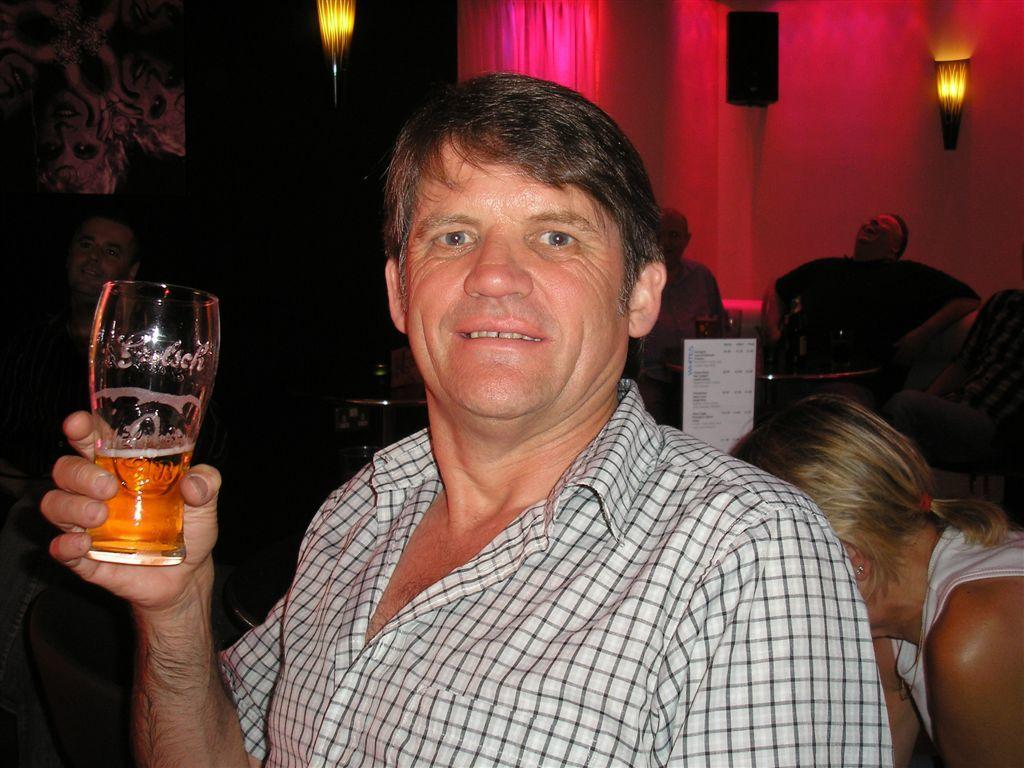What is the man in the image holding? The man is holding a glass in the image. Can you describe the background of the image? There are people in the background of the image. What can be seen on the wall in the image? There are lights and a speaker on the wall in the image. What type of berry is growing on the trees in the image? There are no trees or berries present in the image. Can you tell me how many uncles are visible in the image? There is no mention of an uncle or any family members in the image. 